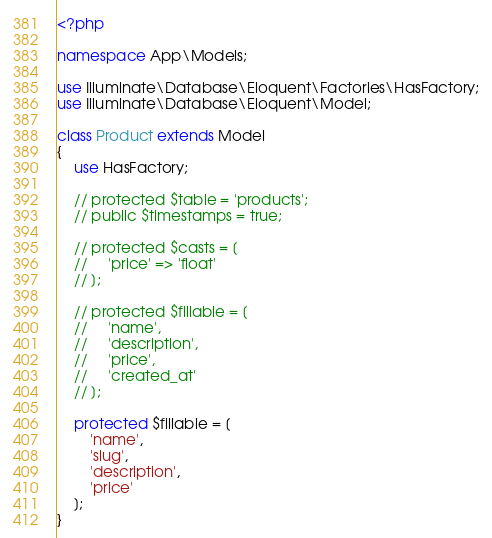<code> <loc_0><loc_0><loc_500><loc_500><_PHP_><?php

namespace App\Models;

use Illuminate\Database\Eloquent\Factories\HasFactory;
use Illuminate\Database\Eloquent\Model;

class Product extends Model
{
    use HasFactory;

    // protected $table = 'products';
    // public $timestamps = true;

    // protected $casts = [
    //     'price' => 'float'
    // ];

    // protected $fillable = [
    //     'name',
    //     'description',
    //     'price',
    //     'created_at'
    // ];
    
    protected $fillable = [
        'name',
        'slug',
        'description',
        'price'
    ];
}</code> 